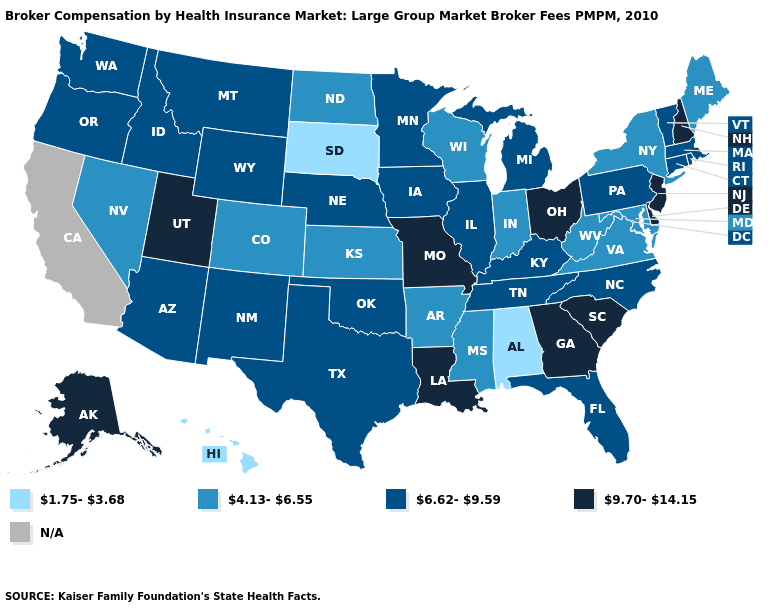What is the value of Pennsylvania?
Give a very brief answer. 6.62-9.59. What is the value of Arizona?
Keep it brief. 6.62-9.59. Among the states that border North Carolina , does Georgia have the highest value?
Answer briefly. Yes. Which states have the lowest value in the South?
Short answer required. Alabama. Does South Dakota have the lowest value in the USA?
Short answer required. Yes. Name the states that have a value in the range N/A?
Short answer required. California. Which states have the highest value in the USA?
Quick response, please. Alaska, Delaware, Georgia, Louisiana, Missouri, New Hampshire, New Jersey, Ohio, South Carolina, Utah. What is the value of Vermont?
Be succinct. 6.62-9.59. Which states have the lowest value in the USA?
Short answer required. Alabama, Hawaii, South Dakota. Among the states that border Arkansas , does Mississippi have the lowest value?
Short answer required. Yes. Does Washington have the highest value in the West?
Be succinct. No. Which states have the lowest value in the USA?
Give a very brief answer. Alabama, Hawaii, South Dakota. What is the highest value in the MidWest ?
Short answer required. 9.70-14.15. What is the highest value in the Northeast ?
Keep it brief. 9.70-14.15. Name the states that have a value in the range N/A?
Write a very short answer. California. 